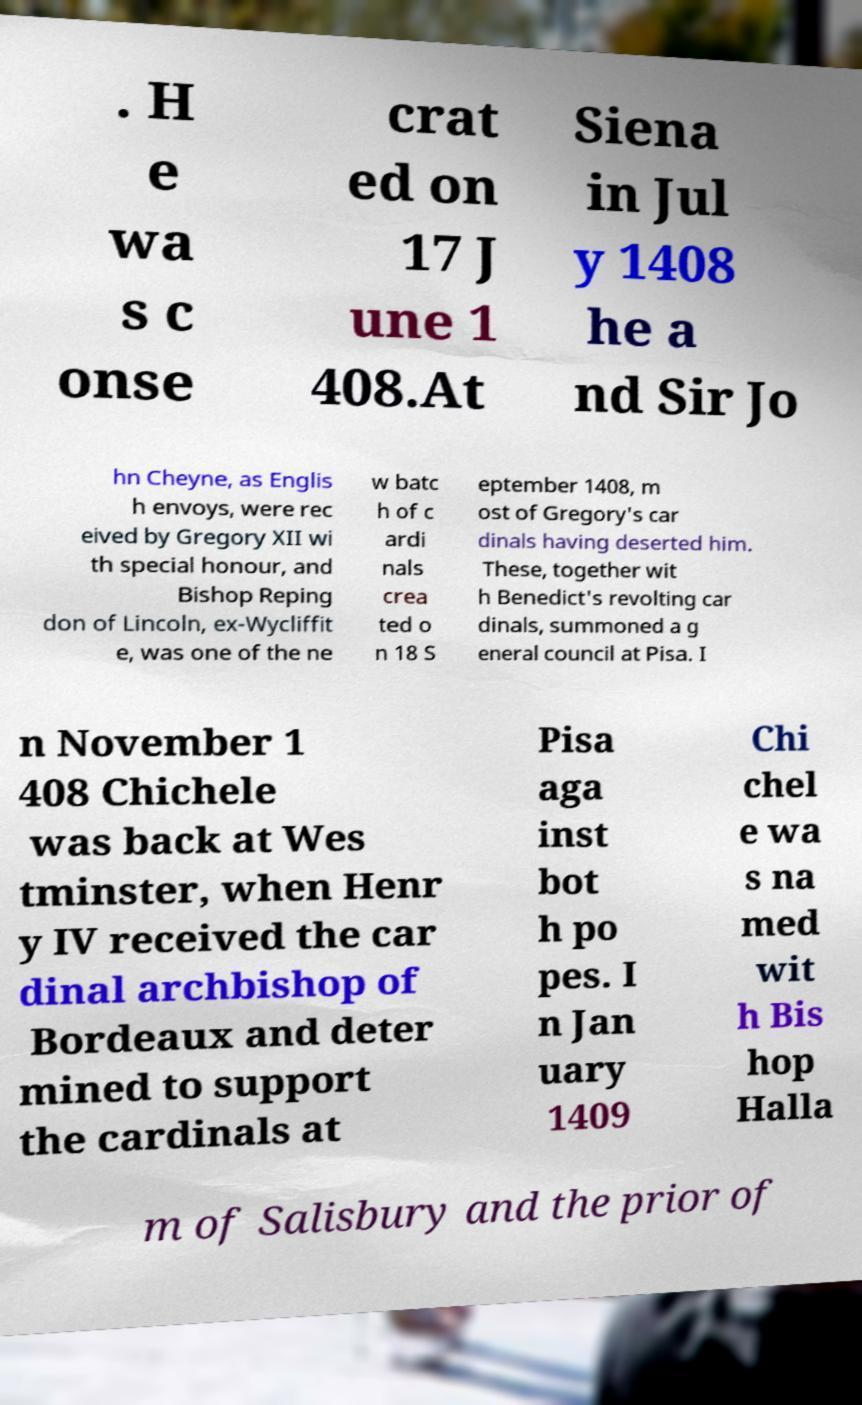Can you read and provide the text displayed in the image?This photo seems to have some interesting text. Can you extract and type it out for me? . H e wa s c onse crat ed on 17 J une 1 408.At Siena in Jul y 1408 he a nd Sir Jo hn Cheyne, as Englis h envoys, were rec eived by Gregory XII wi th special honour, and Bishop Reping don of Lincoln, ex-Wycliffit e, was one of the ne w batc h of c ardi nals crea ted o n 18 S eptember 1408, m ost of Gregory's car dinals having deserted him. These, together wit h Benedict's revolting car dinals, summoned a g eneral council at Pisa. I n November 1 408 Chichele was back at Wes tminster, when Henr y IV received the car dinal archbishop of Bordeaux and deter mined to support the cardinals at Pisa aga inst bot h po pes. I n Jan uary 1409 Chi chel e wa s na med wit h Bis hop Halla m of Salisbury and the prior of 